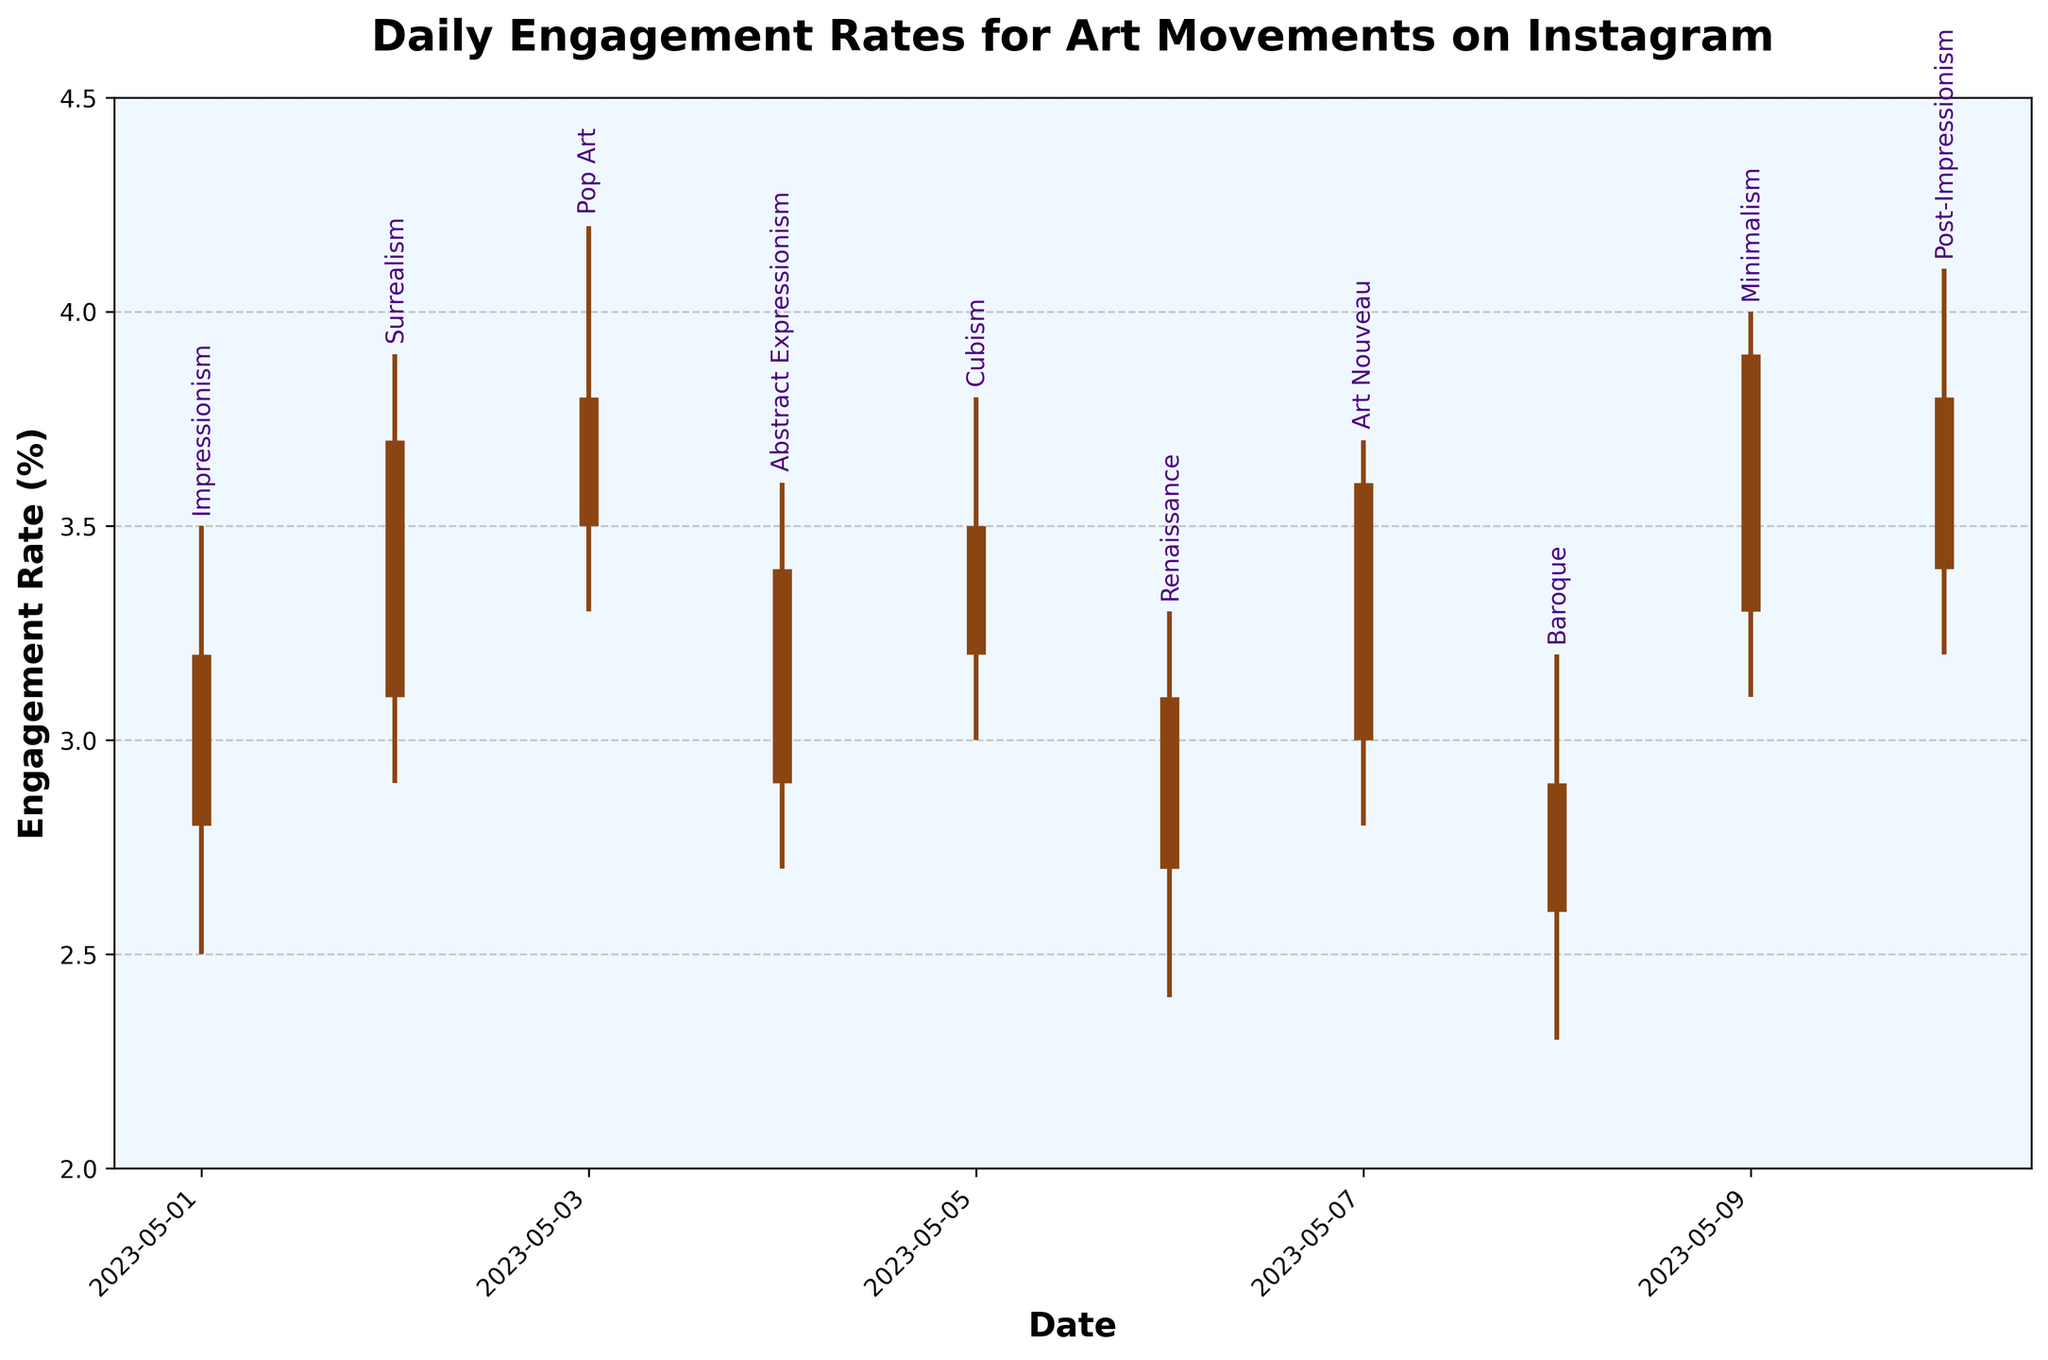What is the date range of the data displayed in the figure? The date range is determined by looking at the x-axis labels and annotations for the first and last data points in the OHLC chart. The first data point is labeled 2023-05-01 and the last data point is labeled 2023-05-10
Answer: 2023-05-01 to 2023-05-10 Which art movement had the highest engagement rate and what was it? To find the highest engagement rate, look at the "High" values for each movement on the y-axis. The highest value is for "Post-Impressionism" with a rate of 4.1%
Answer: Post-Impressionism, 4.1% Which art movement had the lowest opening engagement rate? To find the lowest opening rate, check the "Open" values on the y-axis for each movement. The lowest opening engagement rate is for "Renaissance" with a rate of 2.7%
Answer: Renaissance, 2.7% What is the average closing engagement rate for Impressionism and Surrealism? First, find the closing rates for both movements: Impressionism (3.2) and Surrealism (3.7). Then, calculate the average: (3.2 + 3.7) / 2 = 3.45
Answer: 3.45 Which two art movements experienced the largest fluctuations in engagement rates? Fluctuation is the difference between the high and low values. Calculate the fluctuation for each movement and compare: 
Impressionism (3.5 - 2.5 = 1.0), Surrealism (3.9 - 2.9 = 1.0), Pop Art (4.2 - 3.3 = 0.9), etc.
The largest fluctuations are 1.0 for Impressionism and Surrealism
Answer: Impressionism and Surrealism On which date did Abstract Expressionism have its highest engagement rate? Identify the highest rate for Abstract Expressionism by checking the high value associated with its date. The date is 2023-05-04 with a high of 3.6%
Answer: 2023-05-04 Which art movement's closing engagement rate was lower than its opening rate? Compare the opening and closing rates for each movement:
Impressionism (3.2, 2.8), Surrealism (3.7, 3.1), Pop Art (3.8, 3.5), etc.
Baroque is the only one where the closing rate (2.9) was lower than the opening rate (2.6)
Answer: Baroque Calculate the engagement rate range (High-Low) for Minimalism The high and low engagement rates for Minimalism are 4.0 and 3.1 respectively. Calculate the range: 4.0 - 3.1 = 0.9
Answer: 0.9 How many unique art movements are represented in the chart? Count the distinct art movement labels along the x-axis. The movements listed are Impressionism, Surrealism, Pop Art, Abstract Expressionism, Cubism, Renaissance, Art Nouveau, Baroque, Minimalism, and Post-Impressionism
Answer: 10 Was there any art movement where the engagement rate never dropped below 3.0%? Check the "Low" values for each art movement. Cubism (3.0), Pop Art (3.3), Minimalism (3.1), and Post-Impressionism (3.2) never dropped below 3.0%
Answer: Cubism, Pop Art, Minimalism, and Post-Impressionism 